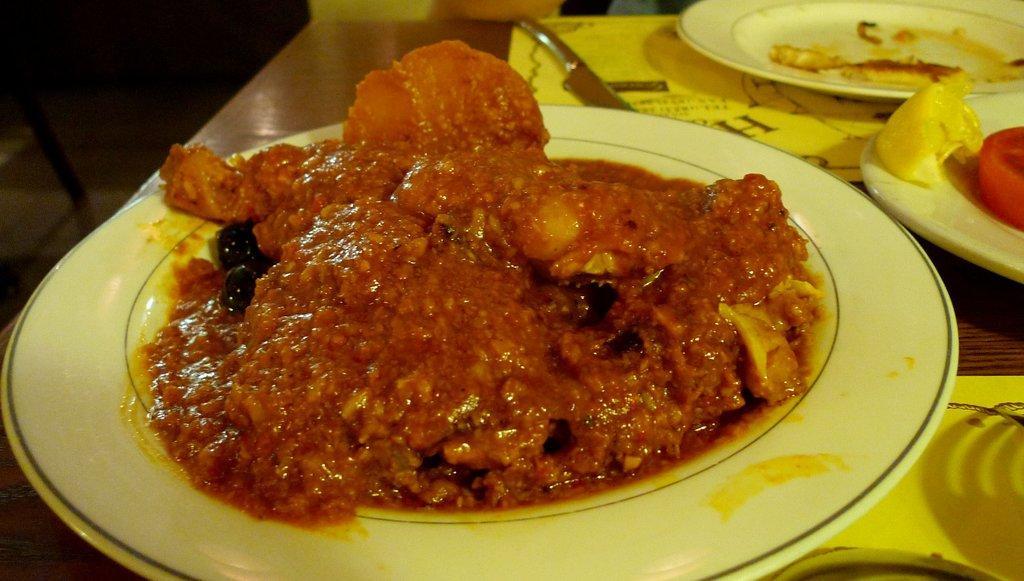Can you describe this image briefly? In this image I can see the plates with food. I can see the food is in brown color and the plate is in white color. To the side I can see few more plates, knife and the spoon. These are on the brown color surface. 